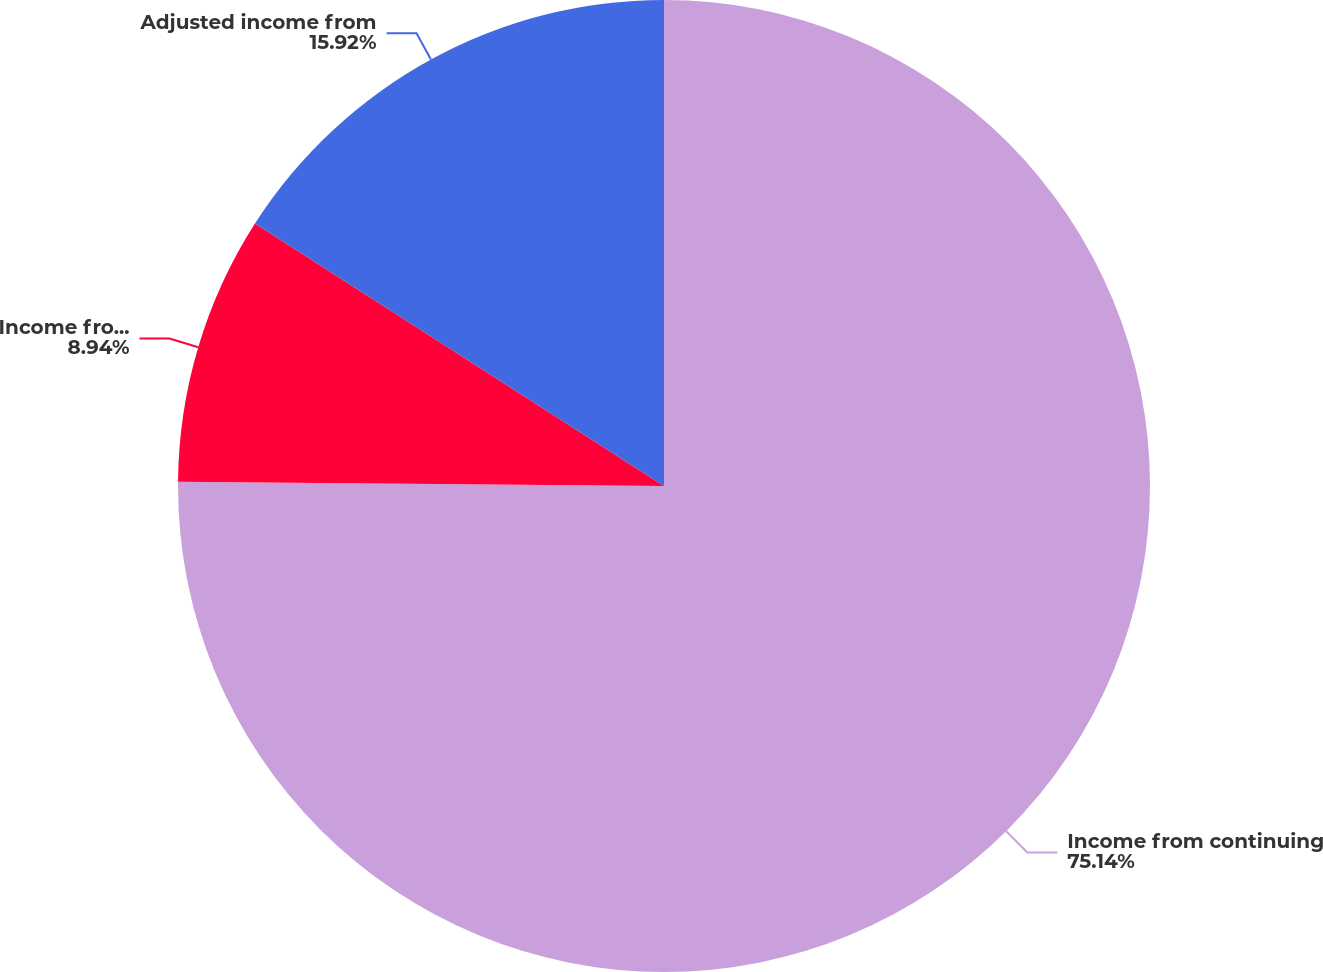<chart> <loc_0><loc_0><loc_500><loc_500><pie_chart><fcel>Income from continuing<fcel>Income from discontinued<fcel>Adjusted income from<nl><fcel>75.14%<fcel>8.94%<fcel>15.92%<nl></chart> 